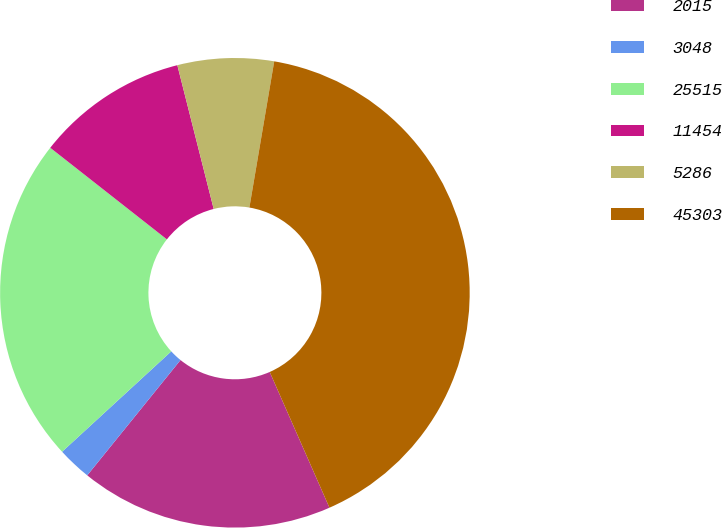Convert chart to OTSL. <chart><loc_0><loc_0><loc_500><loc_500><pie_chart><fcel>2015<fcel>3048<fcel>25515<fcel>11454<fcel>5286<fcel>45303<nl><fcel>17.42%<fcel>2.34%<fcel>22.43%<fcel>10.46%<fcel>6.62%<fcel>40.72%<nl></chart> 